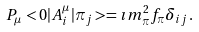Convert formula to latex. <formula><loc_0><loc_0><loc_500><loc_500>P _ { \mu } < 0 | A _ { i } ^ { \mu } | \pi _ { j } > = \imath m _ { \pi } ^ { 2 } f _ { \pi } \delta _ { i j } \, .</formula> 